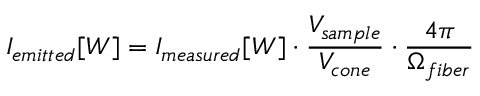<formula> <loc_0><loc_0><loc_500><loc_500>I _ { e m i t t e d } [ W ] = I _ { m e a s u r e d } [ W ] \cdot \frac { V _ { s a m p l e } } { V _ { c o n e } } \cdot \frac { 4 \pi } { \Omega _ { f i b e r } }</formula> 